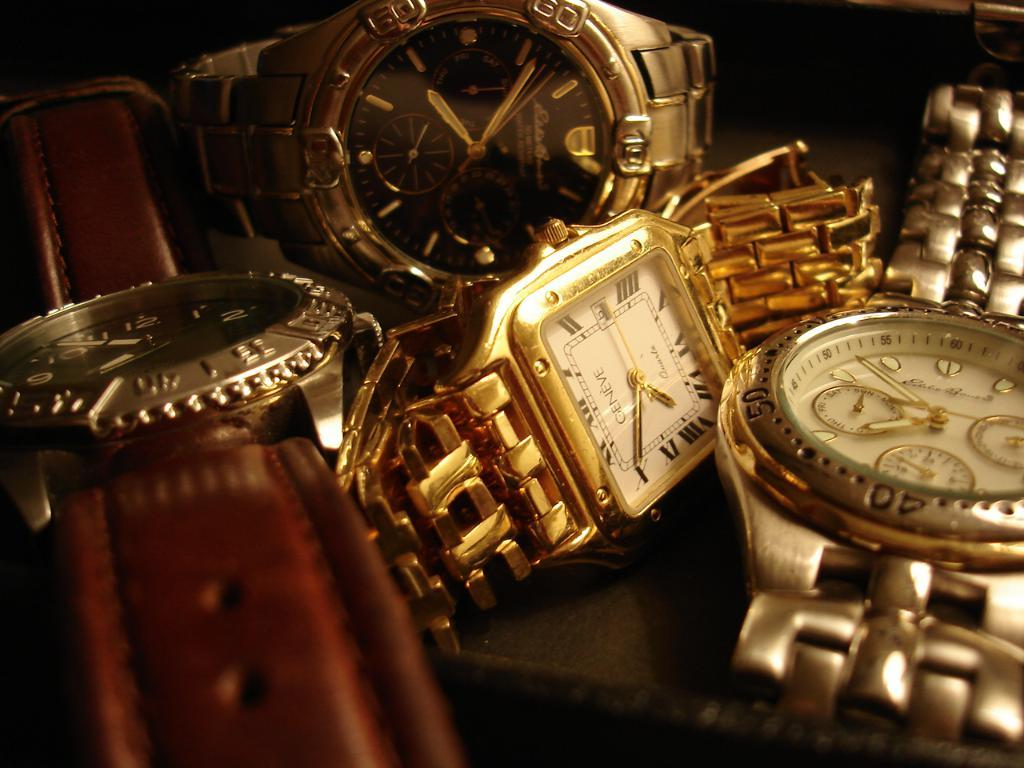<image>
Offer a succinct explanation of the picture presented. Four different watches, including a Ceneve, are laying next to each other. 